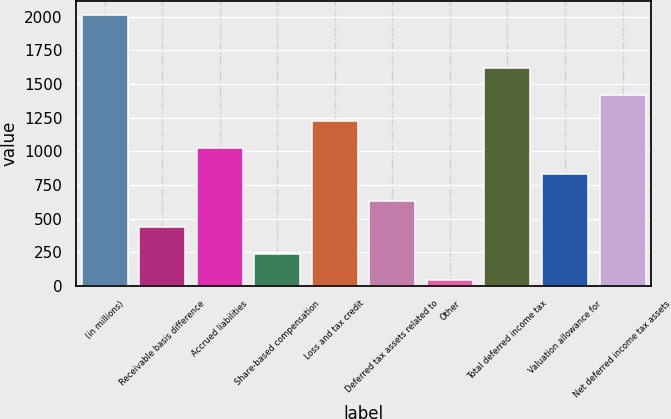Convert chart to OTSL. <chart><loc_0><loc_0><loc_500><loc_500><bar_chart><fcel>(in millions)<fcel>Receivable basis difference<fcel>Accrued liabilities<fcel>Share-based compensation<fcel>Loss and tax credit<fcel>Deferred tax assets related to<fcel>Other<fcel>Total deferred income tax<fcel>Valuation allowance for<fcel>Net deferred income tax assets<nl><fcel>2014<fcel>436.4<fcel>1028<fcel>239.2<fcel>1225.2<fcel>633.6<fcel>42<fcel>1619.6<fcel>830.8<fcel>1422.4<nl></chart> 